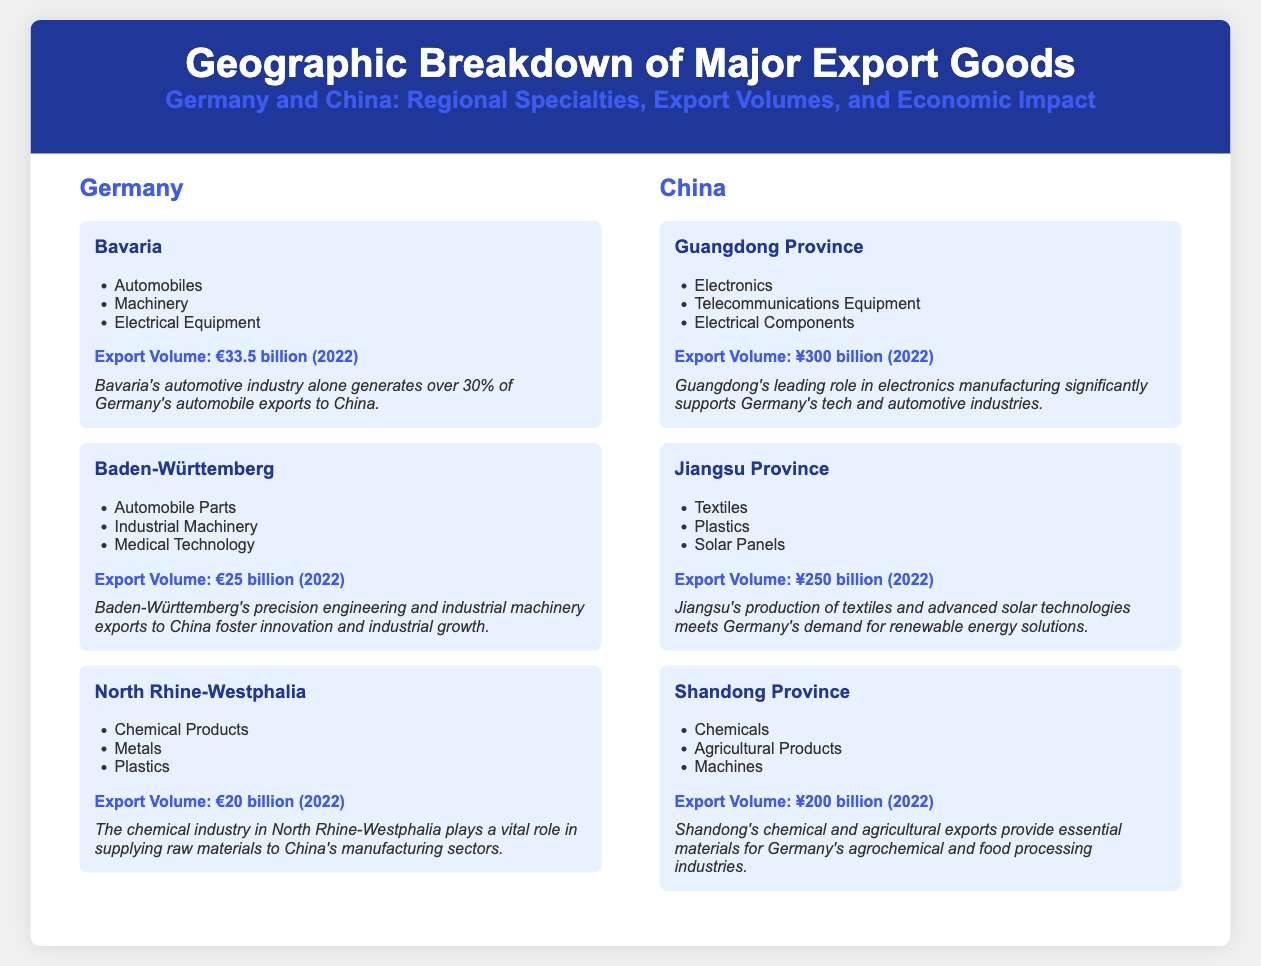What are the major export goods from Bavaria to China? The major export goods from Bavaria to China are automobiles, machinery, and electrical equipment.
Answer: Automobiles, machinery, electrical equipment What is the export volume from North Rhine-Westphalia to China? The export volume from North Rhine-Westphalia to China is €20 billion in 2022.
Answer: €20 billion Which German region has the highest export volume? Bavaria has the highest export volume among the German regions, at €33.5 billion.
Answer: Bavaria What is the export volume from Guangdong Province to Germany? The export volume from Guangdong Province to Germany is ¥300 billion in 2022.
Answer: ¥300 billion Which province's exports meet Germany's demand for renewable energy? Jiangsu Province's production of textiles and advanced solar technologies meets Germany's demand for renewable energy solutions.
Answer: Jiangsu Province What economic impact does North Rhine-Westphalia's chemical industry have? North Rhine-Westphalia's chemical industry plays a vital role in supplying raw materials to China's manufacturing sectors.
Answer: Supplying raw materials Which two regions from Germany focus on automobiles? Bavaria and Baden-Württemberg focus on automobiles as major export goods.
Answer: Bavaria, Baden-Württemberg What type of products does Shandong Province export? Shandong Province exports chemicals, agricultural products, and machines.
Answer: Chemicals, agricultural products, machines What is the importance of Guangdong's electronics manufacturing for Germany? Guangdong's electronics manufacturing significantly supports Germany's tech and automotive industries.
Answer: Supports tech and automotive industries 